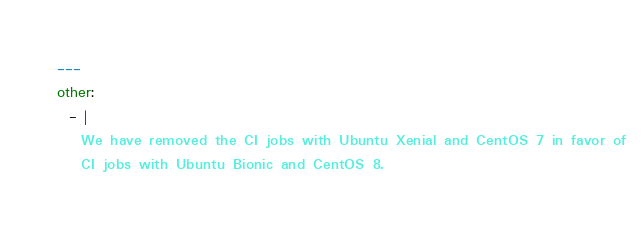<code> <loc_0><loc_0><loc_500><loc_500><_YAML_>---
other:
  - |
    We have removed the CI jobs with Ubuntu Xenial and CentOS 7 in favor of
    CI jobs with Ubuntu Bionic and CentOS 8.

</code> 